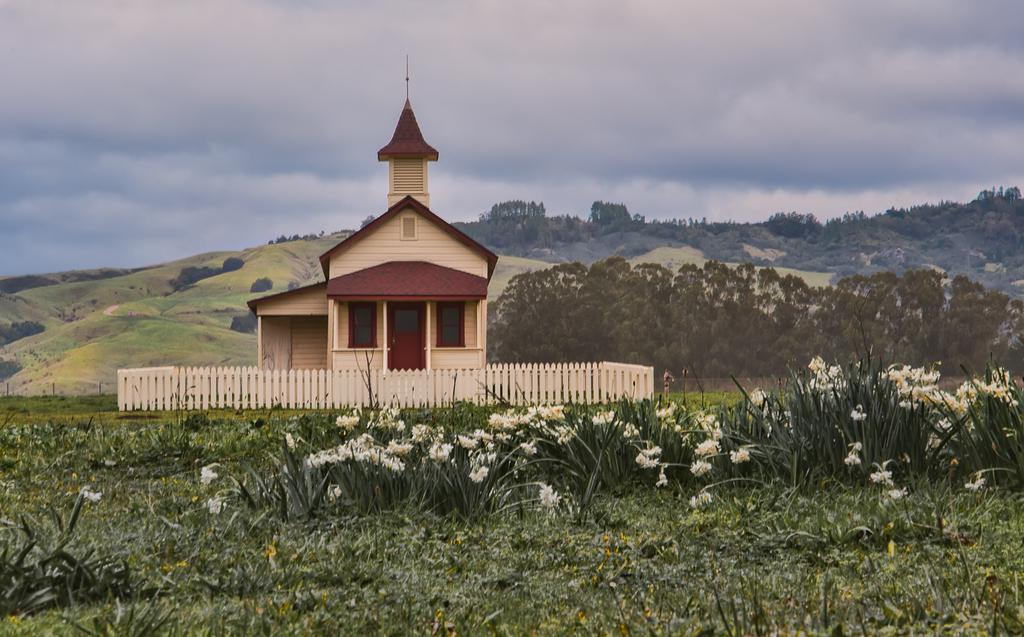What color are the flowers in the image? The flowers in the image are white. What is the color and style of the building in the image? The building in the image is in brown and cream color. What type of vegetation can be seen in the background of the image? The background of the image includes trees in green color. What colors are visible in the sky in the image? The sky is in blue and white color in the image. Can you tell me how many baseballs are visible in the image? There are no baseballs present in the image. What type of force is being applied to the flowers in the image? There is no force being applied to the flowers in the image; they are stationary. 